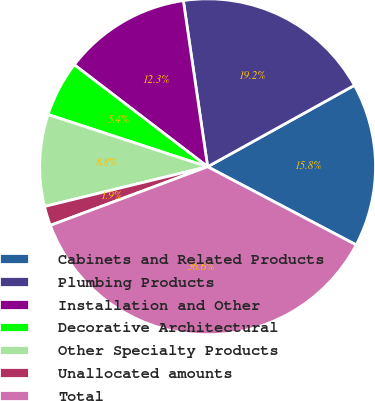Convert chart to OTSL. <chart><loc_0><loc_0><loc_500><loc_500><pie_chart><fcel>Cabinets and Related Products<fcel>Plumbing Products<fcel>Installation and Other<fcel>Decorative Architectural<fcel>Other Specialty Products<fcel>Unallocated amounts<fcel>Total<nl><fcel>15.77%<fcel>19.25%<fcel>12.3%<fcel>5.36%<fcel>8.83%<fcel>1.88%<fcel>36.61%<nl></chart> 